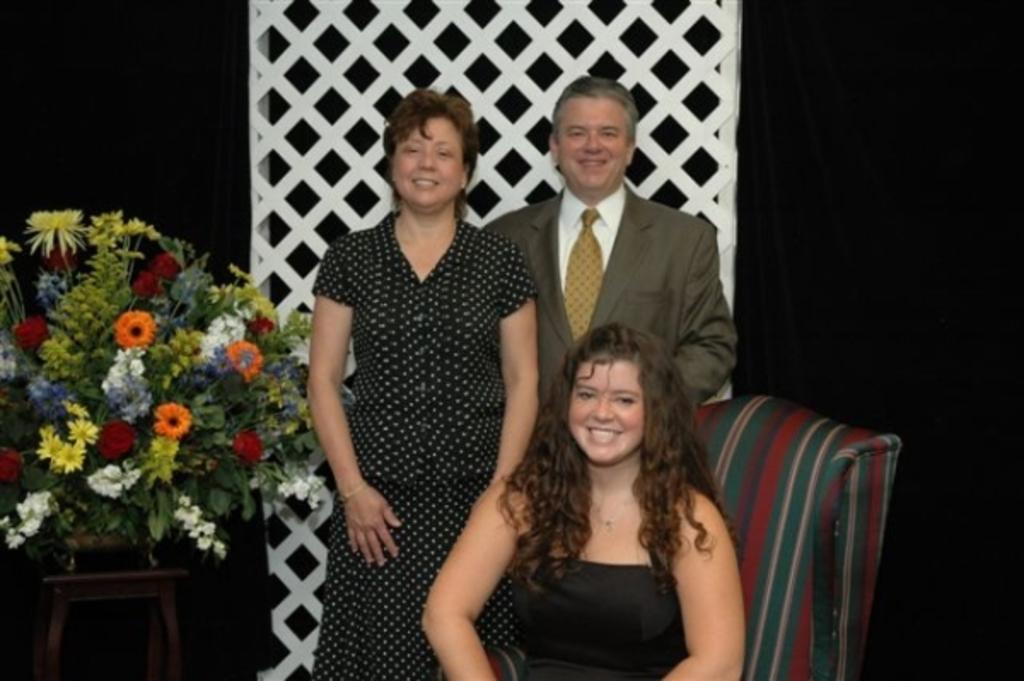Could you give a brief overview of what you see in this image? In this image we can see a girl is sitting on a chair and behind her we can see a man and woman are standing at the mesh stand and on the left side we can see plants and flowers in a pot on the stool. In the background the image is dark. 